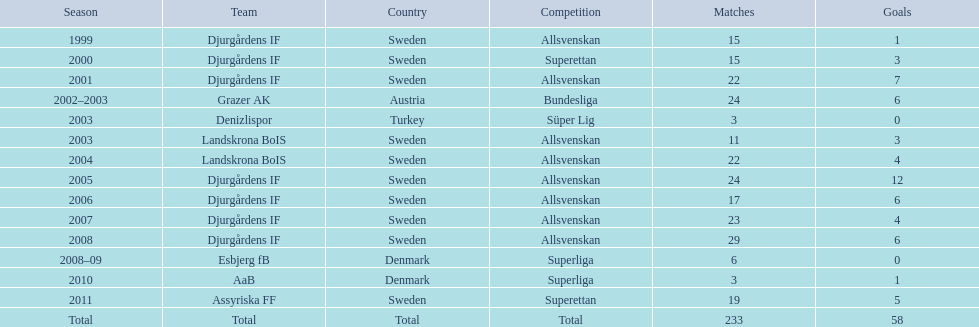What country is team djurgårdens if not from? Sweden. 